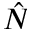Convert formula to latex. <formula><loc_0><loc_0><loc_500><loc_500>\hat { N }</formula> 